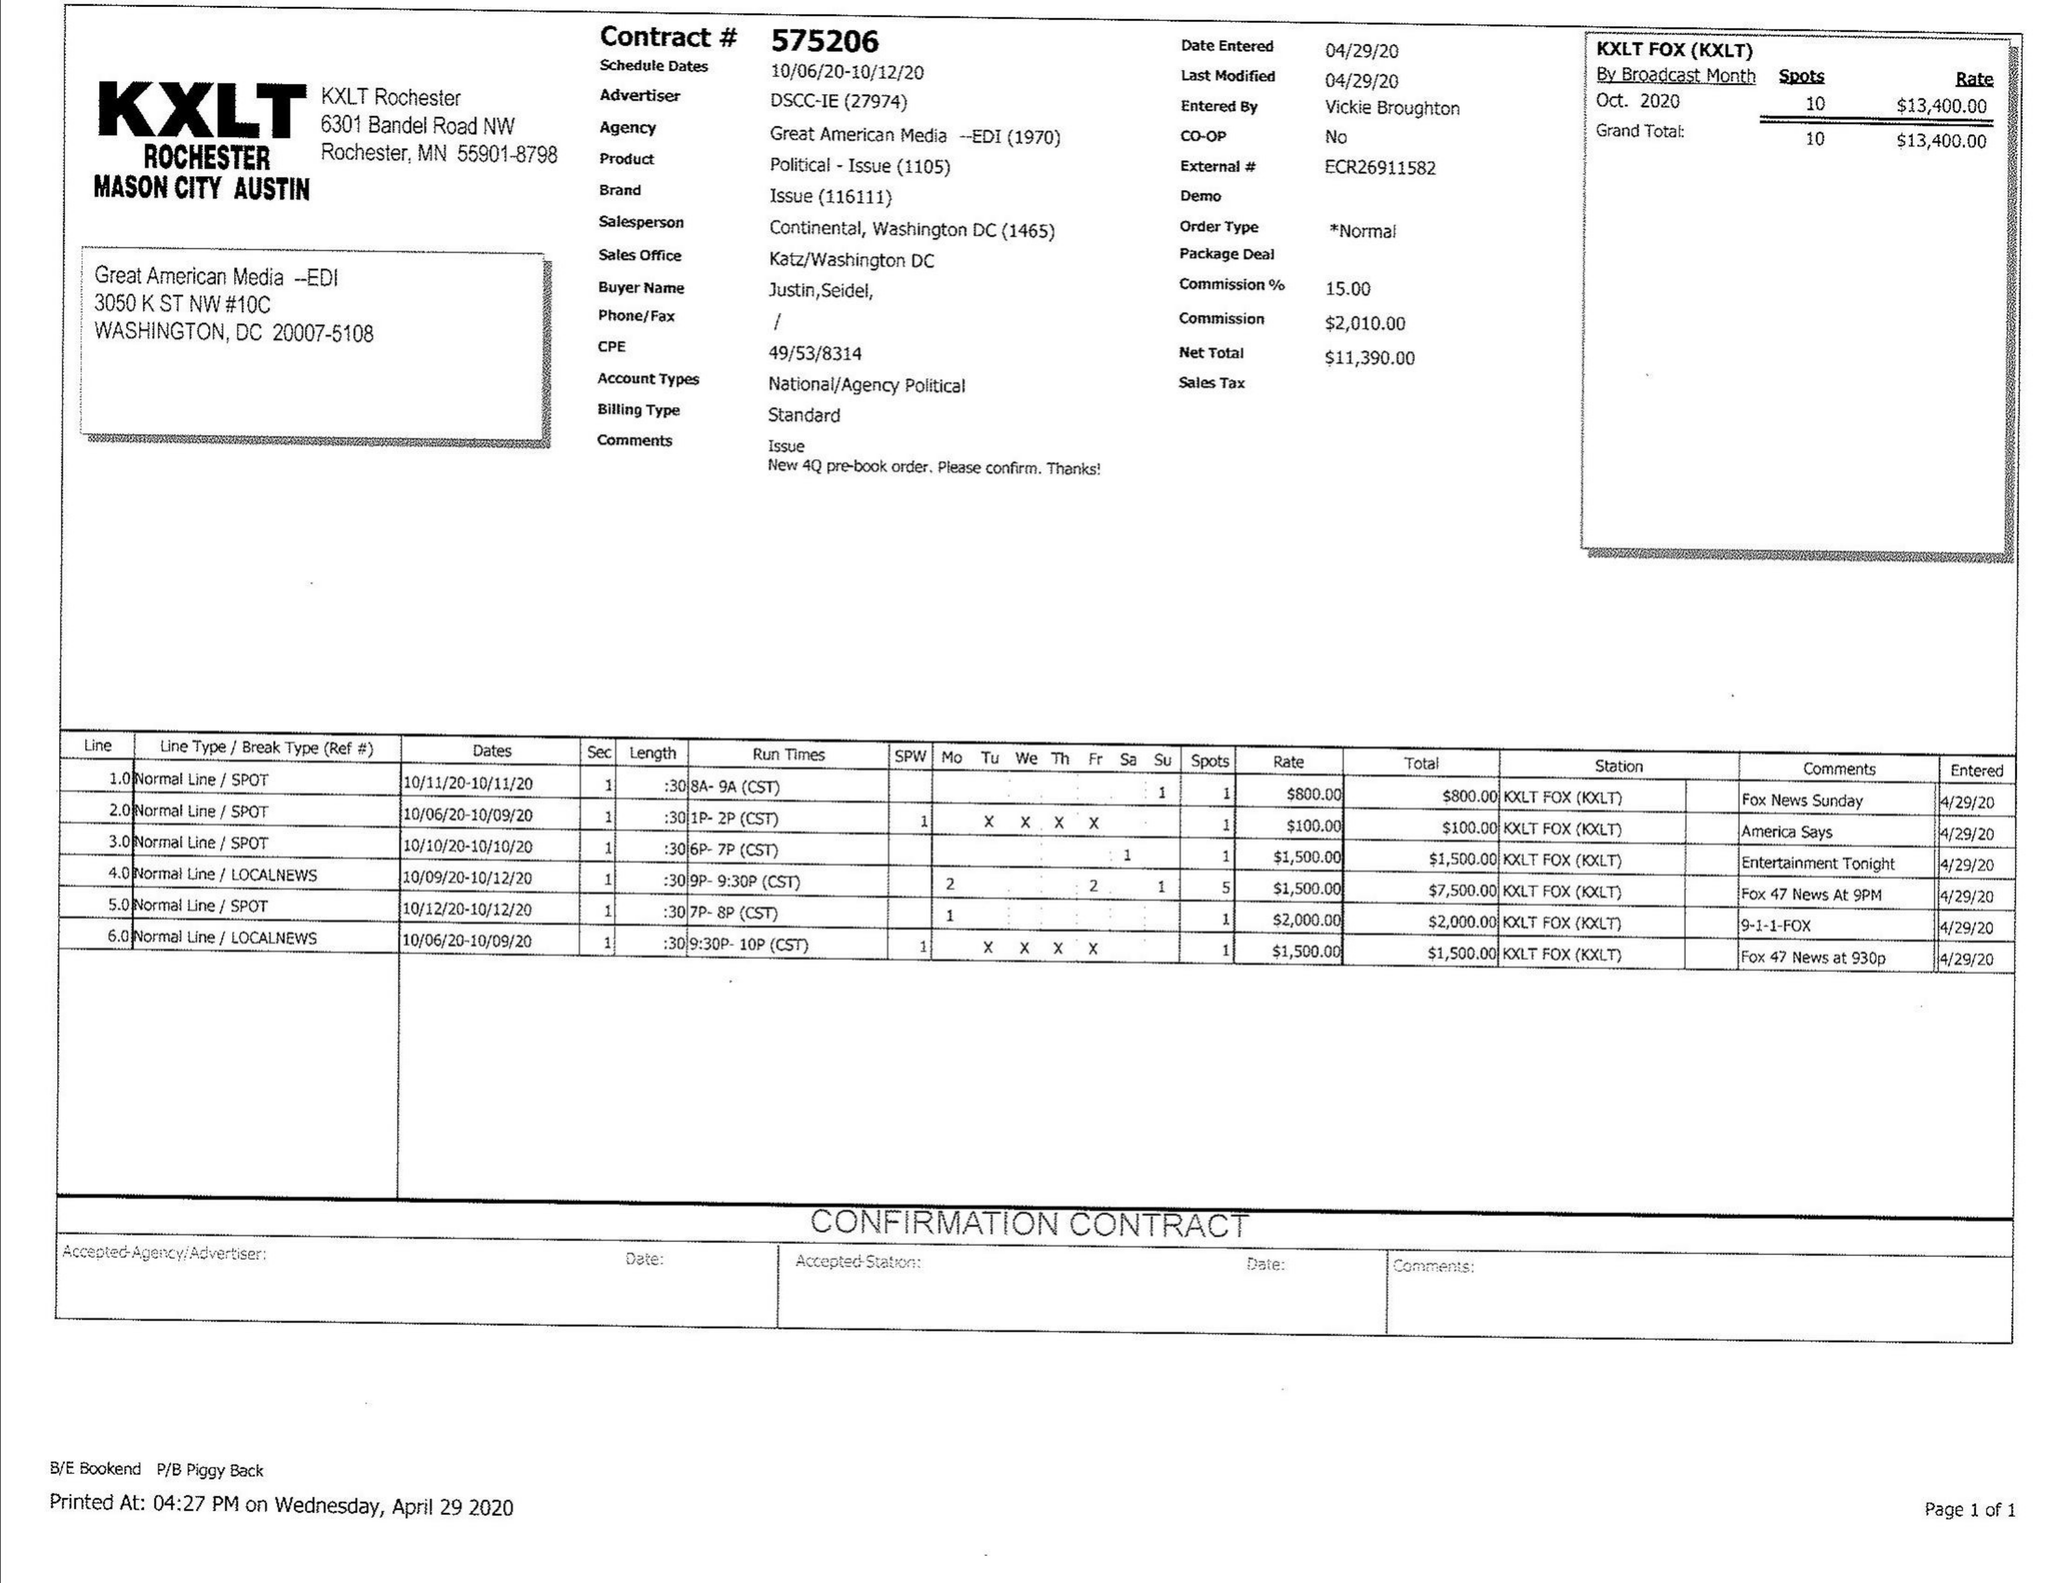What is the value for the gross_amount?
Answer the question using a single word or phrase. 13400.00 